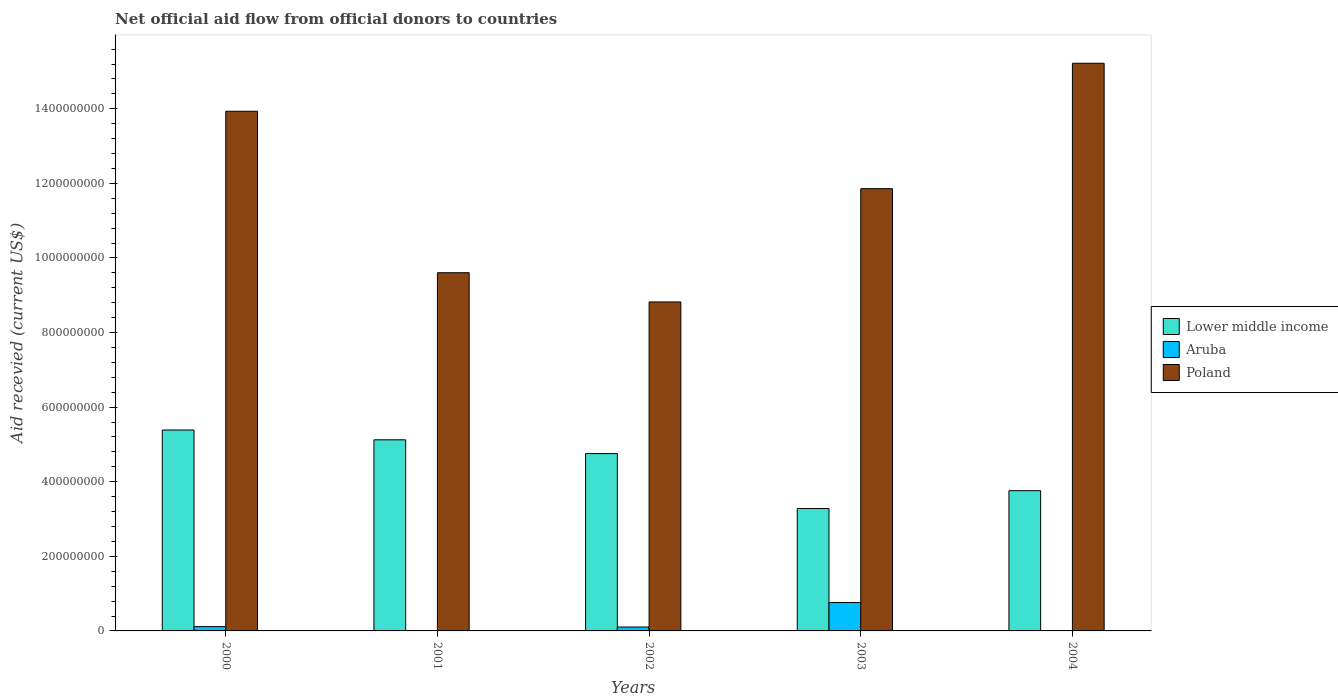How many different coloured bars are there?
Your answer should be compact. 3. How many groups of bars are there?
Offer a very short reply. 5. What is the total aid received in Poland in 2000?
Your answer should be very brief. 1.39e+09. Across all years, what is the maximum total aid received in Poland?
Offer a terse response. 1.52e+09. Across all years, what is the minimum total aid received in Poland?
Give a very brief answer. 8.82e+08. What is the total total aid received in Lower middle income in the graph?
Your response must be concise. 2.23e+09. What is the difference between the total aid received in Poland in 2000 and that in 2001?
Provide a succinct answer. 4.33e+08. What is the difference between the total aid received in Lower middle income in 2000 and the total aid received in Poland in 2003?
Give a very brief answer. -6.47e+08. What is the average total aid received in Lower middle income per year?
Provide a succinct answer. 4.46e+08. In the year 2000, what is the difference between the total aid received in Lower middle income and total aid received in Poland?
Offer a terse response. -8.55e+08. In how many years, is the total aid received in Poland greater than 1160000000 US$?
Provide a succinct answer. 3. What is the ratio of the total aid received in Poland in 2000 to that in 2002?
Provide a succinct answer. 1.58. Is the difference between the total aid received in Lower middle income in 2001 and 2002 greater than the difference between the total aid received in Poland in 2001 and 2002?
Your answer should be compact. No. What is the difference between the highest and the second highest total aid received in Poland?
Offer a terse response. 1.29e+08. What is the difference between the highest and the lowest total aid received in Poland?
Give a very brief answer. 6.40e+08. Is it the case that in every year, the sum of the total aid received in Poland and total aid received in Aruba is greater than the total aid received in Lower middle income?
Provide a short and direct response. Yes. How many bars are there?
Provide a short and direct response. 13. Are all the bars in the graph horizontal?
Give a very brief answer. No. How many years are there in the graph?
Ensure brevity in your answer.  5. What is the difference between two consecutive major ticks on the Y-axis?
Provide a short and direct response. 2.00e+08. Does the graph contain any zero values?
Your answer should be compact. Yes. Does the graph contain grids?
Your response must be concise. No. Where does the legend appear in the graph?
Offer a very short reply. Center right. What is the title of the graph?
Your answer should be compact. Net official aid flow from official donors to countries. What is the label or title of the X-axis?
Offer a very short reply. Years. What is the label or title of the Y-axis?
Make the answer very short. Aid recevied (current US$). What is the Aid recevied (current US$) of Lower middle income in 2000?
Make the answer very short. 5.39e+08. What is the Aid recevied (current US$) of Aruba in 2000?
Your answer should be very brief. 1.15e+07. What is the Aid recevied (current US$) of Poland in 2000?
Provide a short and direct response. 1.39e+09. What is the Aid recevied (current US$) of Lower middle income in 2001?
Your answer should be very brief. 5.12e+08. What is the Aid recevied (current US$) in Poland in 2001?
Keep it short and to the point. 9.60e+08. What is the Aid recevied (current US$) in Lower middle income in 2002?
Offer a terse response. 4.76e+08. What is the Aid recevied (current US$) in Aruba in 2002?
Provide a succinct answer. 1.05e+07. What is the Aid recevied (current US$) of Poland in 2002?
Your response must be concise. 8.82e+08. What is the Aid recevied (current US$) in Lower middle income in 2003?
Offer a terse response. 3.28e+08. What is the Aid recevied (current US$) in Aruba in 2003?
Offer a very short reply. 7.62e+07. What is the Aid recevied (current US$) of Poland in 2003?
Make the answer very short. 1.19e+09. What is the Aid recevied (current US$) in Lower middle income in 2004?
Your answer should be compact. 3.76e+08. What is the Aid recevied (current US$) in Aruba in 2004?
Provide a short and direct response. 0. What is the Aid recevied (current US$) of Poland in 2004?
Your response must be concise. 1.52e+09. Across all years, what is the maximum Aid recevied (current US$) in Lower middle income?
Your answer should be compact. 5.39e+08. Across all years, what is the maximum Aid recevied (current US$) of Aruba?
Make the answer very short. 7.62e+07. Across all years, what is the maximum Aid recevied (current US$) of Poland?
Keep it short and to the point. 1.52e+09. Across all years, what is the minimum Aid recevied (current US$) in Lower middle income?
Your answer should be very brief. 3.28e+08. Across all years, what is the minimum Aid recevied (current US$) of Poland?
Keep it short and to the point. 8.82e+08. What is the total Aid recevied (current US$) in Lower middle income in the graph?
Give a very brief answer. 2.23e+09. What is the total Aid recevied (current US$) of Aruba in the graph?
Offer a terse response. 9.82e+07. What is the total Aid recevied (current US$) in Poland in the graph?
Your response must be concise. 5.94e+09. What is the difference between the Aid recevied (current US$) in Lower middle income in 2000 and that in 2001?
Provide a succinct answer. 2.62e+07. What is the difference between the Aid recevied (current US$) of Poland in 2000 and that in 2001?
Offer a terse response. 4.33e+08. What is the difference between the Aid recevied (current US$) of Lower middle income in 2000 and that in 2002?
Your response must be concise. 6.32e+07. What is the difference between the Aid recevied (current US$) in Aruba in 2000 and that in 2002?
Ensure brevity in your answer.  1.01e+06. What is the difference between the Aid recevied (current US$) of Poland in 2000 and that in 2002?
Provide a short and direct response. 5.11e+08. What is the difference between the Aid recevied (current US$) in Lower middle income in 2000 and that in 2003?
Provide a short and direct response. 2.10e+08. What is the difference between the Aid recevied (current US$) of Aruba in 2000 and that in 2003?
Your answer should be compact. -6.47e+07. What is the difference between the Aid recevied (current US$) in Poland in 2000 and that in 2003?
Give a very brief answer. 2.08e+08. What is the difference between the Aid recevied (current US$) in Lower middle income in 2000 and that in 2004?
Your answer should be very brief. 1.63e+08. What is the difference between the Aid recevied (current US$) in Poland in 2000 and that in 2004?
Provide a short and direct response. -1.29e+08. What is the difference between the Aid recevied (current US$) of Lower middle income in 2001 and that in 2002?
Ensure brevity in your answer.  3.69e+07. What is the difference between the Aid recevied (current US$) in Poland in 2001 and that in 2002?
Your answer should be very brief. 7.83e+07. What is the difference between the Aid recevied (current US$) of Lower middle income in 2001 and that in 2003?
Keep it short and to the point. 1.84e+08. What is the difference between the Aid recevied (current US$) of Poland in 2001 and that in 2003?
Give a very brief answer. -2.25e+08. What is the difference between the Aid recevied (current US$) in Lower middle income in 2001 and that in 2004?
Make the answer very short. 1.36e+08. What is the difference between the Aid recevied (current US$) of Poland in 2001 and that in 2004?
Provide a short and direct response. -5.62e+08. What is the difference between the Aid recevied (current US$) of Lower middle income in 2002 and that in 2003?
Offer a very short reply. 1.47e+08. What is the difference between the Aid recevied (current US$) in Aruba in 2002 and that in 2003?
Your response must be concise. -6.57e+07. What is the difference between the Aid recevied (current US$) in Poland in 2002 and that in 2003?
Your answer should be compact. -3.04e+08. What is the difference between the Aid recevied (current US$) in Lower middle income in 2002 and that in 2004?
Your response must be concise. 9.96e+07. What is the difference between the Aid recevied (current US$) in Poland in 2002 and that in 2004?
Keep it short and to the point. -6.40e+08. What is the difference between the Aid recevied (current US$) of Lower middle income in 2003 and that in 2004?
Give a very brief answer. -4.78e+07. What is the difference between the Aid recevied (current US$) of Poland in 2003 and that in 2004?
Your answer should be compact. -3.36e+08. What is the difference between the Aid recevied (current US$) of Lower middle income in 2000 and the Aid recevied (current US$) of Poland in 2001?
Offer a terse response. -4.22e+08. What is the difference between the Aid recevied (current US$) of Aruba in 2000 and the Aid recevied (current US$) of Poland in 2001?
Make the answer very short. -9.49e+08. What is the difference between the Aid recevied (current US$) of Lower middle income in 2000 and the Aid recevied (current US$) of Aruba in 2002?
Ensure brevity in your answer.  5.28e+08. What is the difference between the Aid recevied (current US$) of Lower middle income in 2000 and the Aid recevied (current US$) of Poland in 2002?
Offer a very short reply. -3.43e+08. What is the difference between the Aid recevied (current US$) of Aruba in 2000 and the Aid recevied (current US$) of Poland in 2002?
Give a very brief answer. -8.71e+08. What is the difference between the Aid recevied (current US$) in Lower middle income in 2000 and the Aid recevied (current US$) in Aruba in 2003?
Provide a short and direct response. 4.62e+08. What is the difference between the Aid recevied (current US$) of Lower middle income in 2000 and the Aid recevied (current US$) of Poland in 2003?
Make the answer very short. -6.47e+08. What is the difference between the Aid recevied (current US$) of Aruba in 2000 and the Aid recevied (current US$) of Poland in 2003?
Ensure brevity in your answer.  -1.17e+09. What is the difference between the Aid recevied (current US$) of Lower middle income in 2000 and the Aid recevied (current US$) of Poland in 2004?
Your answer should be compact. -9.83e+08. What is the difference between the Aid recevied (current US$) in Aruba in 2000 and the Aid recevied (current US$) in Poland in 2004?
Your answer should be very brief. -1.51e+09. What is the difference between the Aid recevied (current US$) of Lower middle income in 2001 and the Aid recevied (current US$) of Aruba in 2002?
Ensure brevity in your answer.  5.02e+08. What is the difference between the Aid recevied (current US$) in Lower middle income in 2001 and the Aid recevied (current US$) in Poland in 2002?
Your answer should be compact. -3.70e+08. What is the difference between the Aid recevied (current US$) in Lower middle income in 2001 and the Aid recevied (current US$) in Aruba in 2003?
Your answer should be compact. 4.36e+08. What is the difference between the Aid recevied (current US$) of Lower middle income in 2001 and the Aid recevied (current US$) of Poland in 2003?
Make the answer very short. -6.73e+08. What is the difference between the Aid recevied (current US$) of Lower middle income in 2001 and the Aid recevied (current US$) of Poland in 2004?
Keep it short and to the point. -1.01e+09. What is the difference between the Aid recevied (current US$) in Lower middle income in 2002 and the Aid recevied (current US$) in Aruba in 2003?
Provide a short and direct response. 3.99e+08. What is the difference between the Aid recevied (current US$) in Lower middle income in 2002 and the Aid recevied (current US$) in Poland in 2003?
Keep it short and to the point. -7.10e+08. What is the difference between the Aid recevied (current US$) of Aruba in 2002 and the Aid recevied (current US$) of Poland in 2003?
Keep it short and to the point. -1.18e+09. What is the difference between the Aid recevied (current US$) in Lower middle income in 2002 and the Aid recevied (current US$) in Poland in 2004?
Your response must be concise. -1.05e+09. What is the difference between the Aid recevied (current US$) of Aruba in 2002 and the Aid recevied (current US$) of Poland in 2004?
Ensure brevity in your answer.  -1.51e+09. What is the difference between the Aid recevied (current US$) of Lower middle income in 2003 and the Aid recevied (current US$) of Poland in 2004?
Your response must be concise. -1.19e+09. What is the difference between the Aid recevied (current US$) in Aruba in 2003 and the Aid recevied (current US$) in Poland in 2004?
Your answer should be very brief. -1.45e+09. What is the average Aid recevied (current US$) of Lower middle income per year?
Your answer should be compact. 4.46e+08. What is the average Aid recevied (current US$) of Aruba per year?
Your answer should be very brief. 1.96e+07. What is the average Aid recevied (current US$) in Poland per year?
Your response must be concise. 1.19e+09. In the year 2000, what is the difference between the Aid recevied (current US$) in Lower middle income and Aid recevied (current US$) in Aruba?
Make the answer very short. 5.27e+08. In the year 2000, what is the difference between the Aid recevied (current US$) in Lower middle income and Aid recevied (current US$) in Poland?
Your answer should be compact. -8.55e+08. In the year 2000, what is the difference between the Aid recevied (current US$) in Aruba and Aid recevied (current US$) in Poland?
Keep it short and to the point. -1.38e+09. In the year 2001, what is the difference between the Aid recevied (current US$) of Lower middle income and Aid recevied (current US$) of Poland?
Provide a short and direct response. -4.48e+08. In the year 2002, what is the difference between the Aid recevied (current US$) of Lower middle income and Aid recevied (current US$) of Aruba?
Give a very brief answer. 4.65e+08. In the year 2002, what is the difference between the Aid recevied (current US$) of Lower middle income and Aid recevied (current US$) of Poland?
Provide a short and direct response. -4.07e+08. In the year 2002, what is the difference between the Aid recevied (current US$) in Aruba and Aid recevied (current US$) in Poland?
Your answer should be very brief. -8.72e+08. In the year 2003, what is the difference between the Aid recevied (current US$) in Lower middle income and Aid recevied (current US$) in Aruba?
Make the answer very short. 2.52e+08. In the year 2003, what is the difference between the Aid recevied (current US$) in Lower middle income and Aid recevied (current US$) in Poland?
Offer a very short reply. -8.58e+08. In the year 2003, what is the difference between the Aid recevied (current US$) in Aruba and Aid recevied (current US$) in Poland?
Give a very brief answer. -1.11e+09. In the year 2004, what is the difference between the Aid recevied (current US$) in Lower middle income and Aid recevied (current US$) in Poland?
Make the answer very short. -1.15e+09. What is the ratio of the Aid recevied (current US$) of Lower middle income in 2000 to that in 2001?
Provide a short and direct response. 1.05. What is the ratio of the Aid recevied (current US$) in Poland in 2000 to that in 2001?
Your answer should be compact. 1.45. What is the ratio of the Aid recevied (current US$) of Lower middle income in 2000 to that in 2002?
Your answer should be compact. 1.13. What is the ratio of the Aid recevied (current US$) in Aruba in 2000 to that in 2002?
Offer a terse response. 1.1. What is the ratio of the Aid recevied (current US$) in Poland in 2000 to that in 2002?
Your answer should be compact. 1.58. What is the ratio of the Aid recevied (current US$) of Lower middle income in 2000 to that in 2003?
Your answer should be compact. 1.64. What is the ratio of the Aid recevied (current US$) of Aruba in 2000 to that in 2003?
Your answer should be compact. 0.15. What is the ratio of the Aid recevied (current US$) of Poland in 2000 to that in 2003?
Your response must be concise. 1.18. What is the ratio of the Aid recevied (current US$) in Lower middle income in 2000 to that in 2004?
Your response must be concise. 1.43. What is the ratio of the Aid recevied (current US$) in Poland in 2000 to that in 2004?
Make the answer very short. 0.92. What is the ratio of the Aid recevied (current US$) of Lower middle income in 2001 to that in 2002?
Your response must be concise. 1.08. What is the ratio of the Aid recevied (current US$) of Poland in 2001 to that in 2002?
Your response must be concise. 1.09. What is the ratio of the Aid recevied (current US$) of Lower middle income in 2001 to that in 2003?
Make the answer very short. 1.56. What is the ratio of the Aid recevied (current US$) in Poland in 2001 to that in 2003?
Provide a succinct answer. 0.81. What is the ratio of the Aid recevied (current US$) in Lower middle income in 2001 to that in 2004?
Offer a terse response. 1.36. What is the ratio of the Aid recevied (current US$) in Poland in 2001 to that in 2004?
Your response must be concise. 0.63. What is the ratio of the Aid recevied (current US$) of Lower middle income in 2002 to that in 2003?
Give a very brief answer. 1.45. What is the ratio of the Aid recevied (current US$) of Aruba in 2002 to that in 2003?
Ensure brevity in your answer.  0.14. What is the ratio of the Aid recevied (current US$) in Poland in 2002 to that in 2003?
Keep it short and to the point. 0.74. What is the ratio of the Aid recevied (current US$) of Lower middle income in 2002 to that in 2004?
Make the answer very short. 1.26. What is the ratio of the Aid recevied (current US$) of Poland in 2002 to that in 2004?
Provide a short and direct response. 0.58. What is the ratio of the Aid recevied (current US$) in Lower middle income in 2003 to that in 2004?
Your answer should be compact. 0.87. What is the ratio of the Aid recevied (current US$) of Poland in 2003 to that in 2004?
Provide a succinct answer. 0.78. What is the difference between the highest and the second highest Aid recevied (current US$) of Lower middle income?
Your response must be concise. 2.62e+07. What is the difference between the highest and the second highest Aid recevied (current US$) of Aruba?
Ensure brevity in your answer.  6.47e+07. What is the difference between the highest and the second highest Aid recevied (current US$) of Poland?
Offer a terse response. 1.29e+08. What is the difference between the highest and the lowest Aid recevied (current US$) of Lower middle income?
Your answer should be compact. 2.10e+08. What is the difference between the highest and the lowest Aid recevied (current US$) in Aruba?
Your answer should be compact. 7.62e+07. What is the difference between the highest and the lowest Aid recevied (current US$) in Poland?
Your answer should be compact. 6.40e+08. 